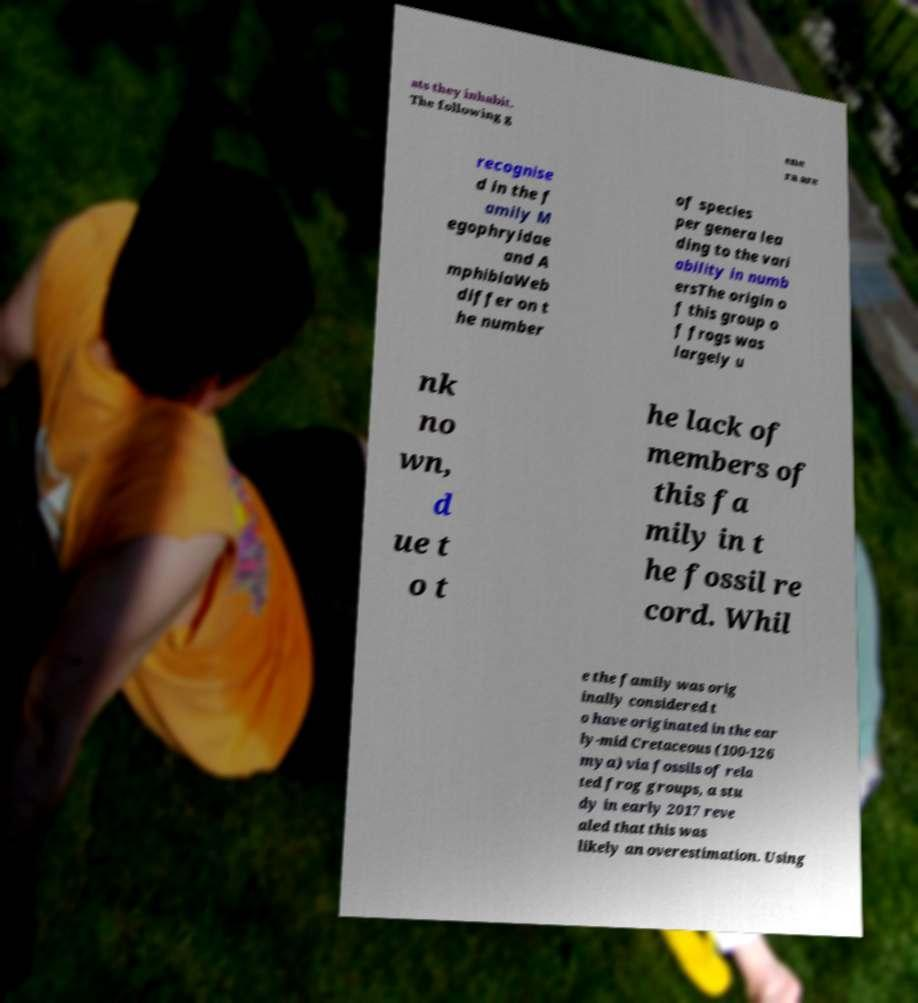What messages or text are displayed in this image? I need them in a readable, typed format. ats they inhabit. The following g ene ra are recognise d in the f amily M egophryidae and A mphibiaWeb differ on t he number of species per genera lea ding to the vari ability in numb ersThe origin o f this group o f frogs was largely u nk no wn, d ue t o t he lack of members of this fa mily in t he fossil re cord. Whil e the family was orig inally considered t o have originated in the ear ly-mid Cretaceous (100-126 mya) via fossils of rela ted frog groups, a stu dy in early 2017 reve aled that this was likely an overestimation. Using 